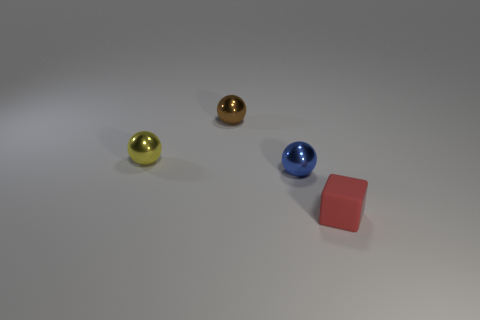What color is the thing that is in front of the tiny yellow metallic thing and behind the tiny matte thing?
Ensure brevity in your answer.  Blue. What color is the block?
Offer a terse response. Red. Does the tiny block have the same material as the tiny object behind the small yellow ball?
Provide a short and direct response. No. There is a tiny yellow thing that is made of the same material as the tiny brown object; what shape is it?
Offer a terse response. Sphere. What is the color of the rubber cube that is the same size as the blue metal sphere?
Keep it short and to the point. Red. There is a metal sphere in front of the yellow shiny sphere; is it the same size as the tiny block?
Your answer should be very brief. Yes. What number of tiny gray spheres are there?
Your answer should be compact. 0. What number of balls are either tiny yellow matte things or small blue metal objects?
Offer a very short reply. 1. There is a thing that is in front of the blue metallic sphere; what number of blue shiny balls are in front of it?
Your answer should be very brief. 0. Is the material of the tiny yellow ball the same as the small blue sphere?
Your answer should be very brief. Yes. 